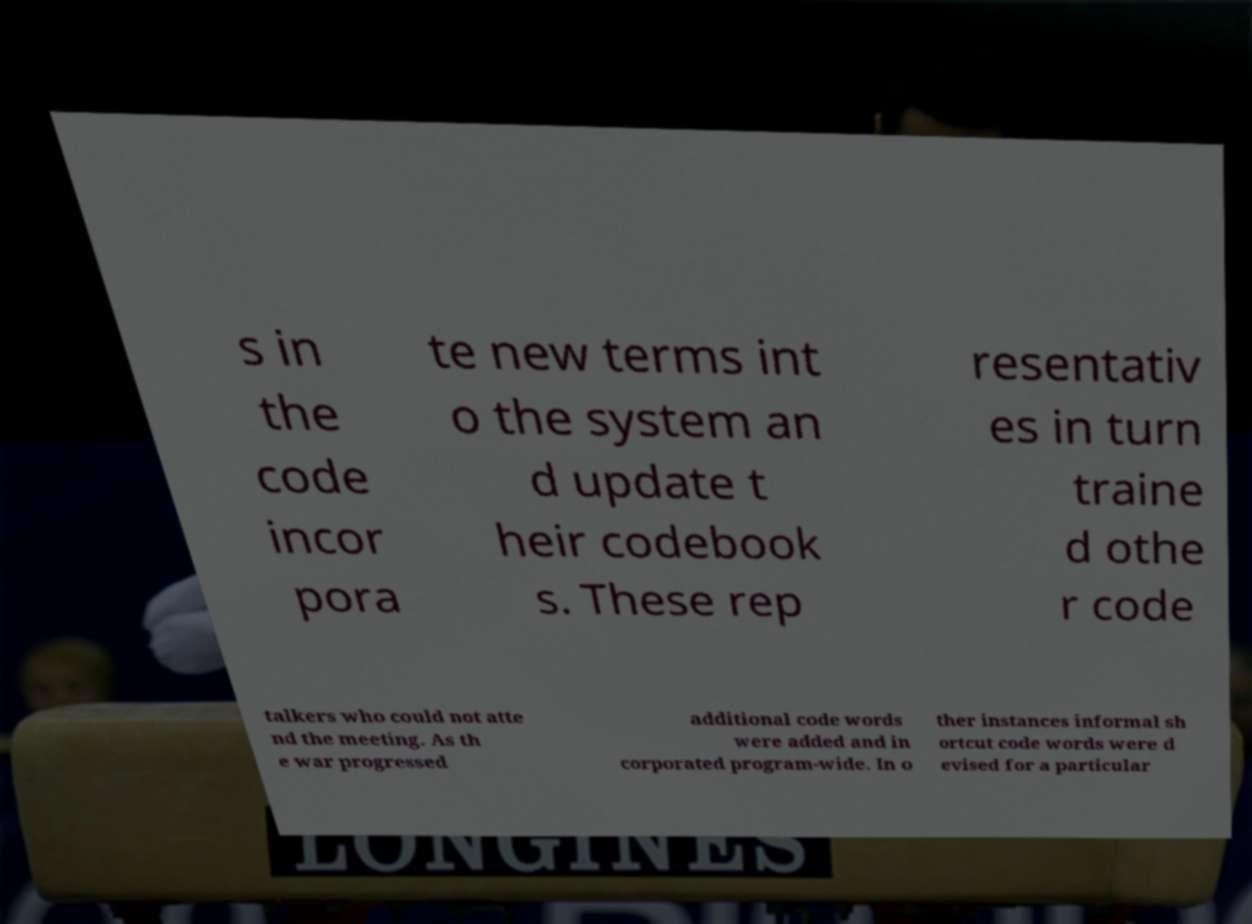There's text embedded in this image that I need extracted. Can you transcribe it verbatim? s in the code incor pora te new terms int o the system an d update t heir codebook s. These rep resentativ es in turn traine d othe r code talkers who could not atte nd the meeting. As th e war progressed additional code words were added and in corporated program-wide. In o ther instances informal sh ortcut code words were d evised for a particular 